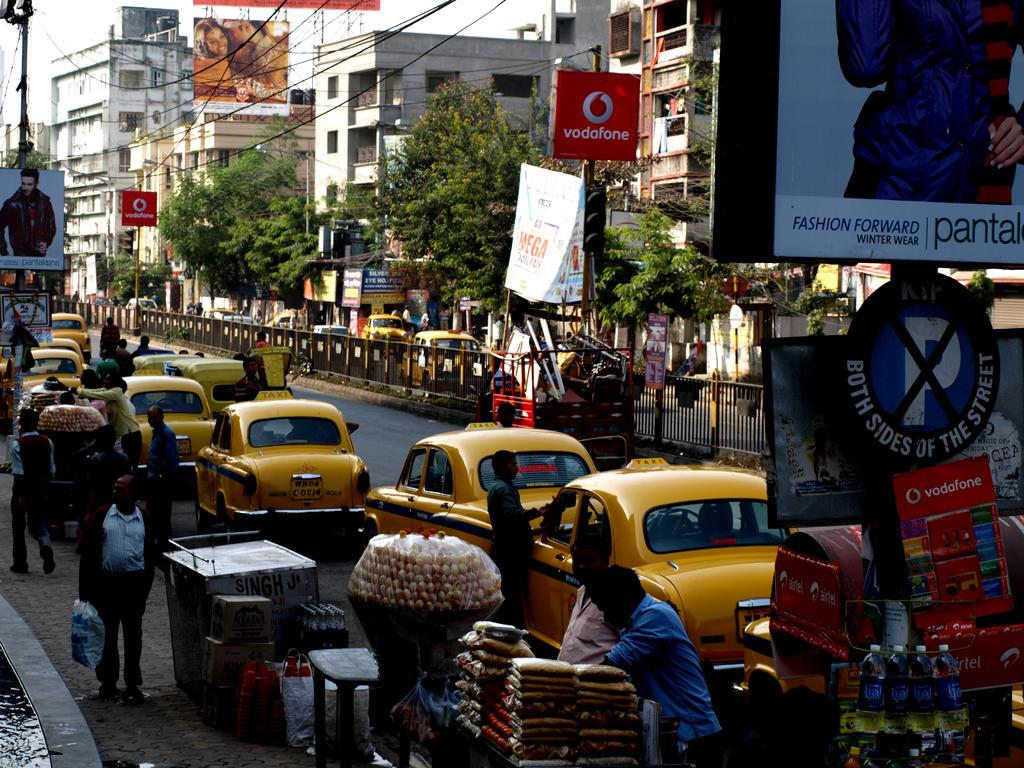<image>
Present a compact description of the photo's key features. A row of old style taxis are on a busy street with open air markets under a sign that says Vodafone. 